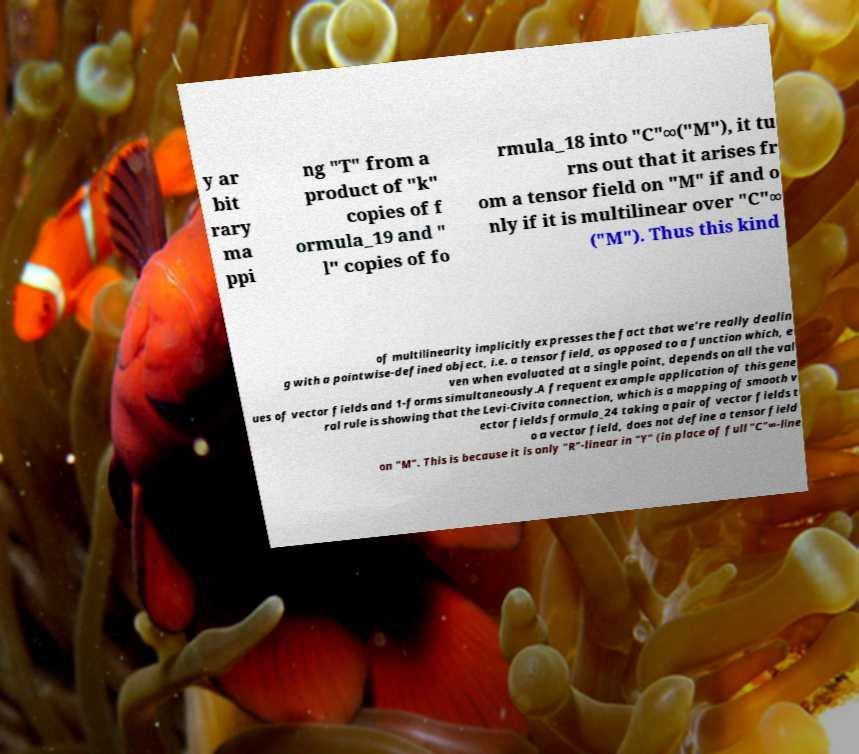What messages or text are displayed in this image? I need them in a readable, typed format. y ar bit rary ma ppi ng "T" from a product of "k" copies of f ormula_19 and " l" copies of fo rmula_18 into "C"∞("M"), it tu rns out that it arises fr om a tensor field on "M" if and o nly if it is multilinear over "C"∞ ("M"). Thus this kind of multilinearity implicitly expresses the fact that we're really dealin g with a pointwise-defined object, i.e. a tensor field, as opposed to a function which, e ven when evaluated at a single point, depends on all the val ues of vector fields and 1-forms simultaneously.A frequent example application of this gene ral rule is showing that the Levi-Civita connection, which is a mapping of smooth v ector fields formula_24 taking a pair of vector fields t o a vector field, does not define a tensor field on "M". This is because it is only "R"-linear in "Y" (in place of full "C"∞-line 